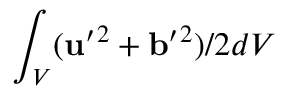<formula> <loc_0><loc_0><loc_500><loc_500>\int _ { V } ( { u } ^ { \prime ^ { 2 } + { b } ^ { \prime ^ { 2 } ) / 2 d V</formula> 